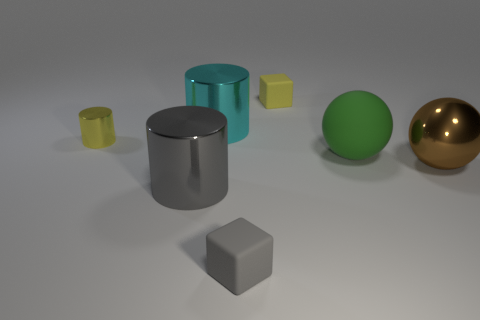What number of other things are the same material as the tiny cylinder?
Offer a terse response. 3. How many gray objects are either big shiny things or big metal cylinders?
Offer a very short reply. 1. There is a big shiny cylinder that is in front of the green object; how many tiny yellow cylinders are on the left side of it?
Keep it short and to the point. 1. What number of other objects are there of the same shape as the green matte object?
Offer a terse response. 1. What is the material of the block that is the same color as the small metal cylinder?
Keep it short and to the point. Rubber. What number of rubber cubes are the same color as the small metallic object?
Offer a very short reply. 1. The small object that is the same material as the yellow block is what color?
Provide a short and direct response. Gray. Is there a cylinder of the same size as the gray matte object?
Offer a terse response. Yes. Is the number of large cyan cylinders on the left side of the brown shiny sphere greater than the number of tiny yellow metal cylinders that are in front of the green object?
Keep it short and to the point. Yes. Do the gray object that is on the right side of the big gray object and the large thing that is behind the yellow shiny cylinder have the same material?
Provide a succinct answer. No. 